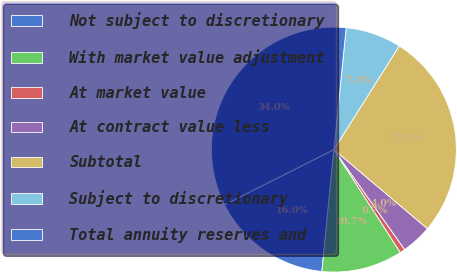Convert chart. <chart><loc_0><loc_0><loc_500><loc_500><pie_chart><fcel>Not subject to discretionary<fcel>With market value adjustment<fcel>At market value<fcel>At contract value less<fcel>Subtotal<fcel>Subject to discretionary<fcel>Total annuity reserves and<nl><fcel>16.0%<fcel>10.69%<fcel>0.68%<fcel>4.02%<fcel>27.23%<fcel>7.35%<fcel>34.04%<nl></chart> 